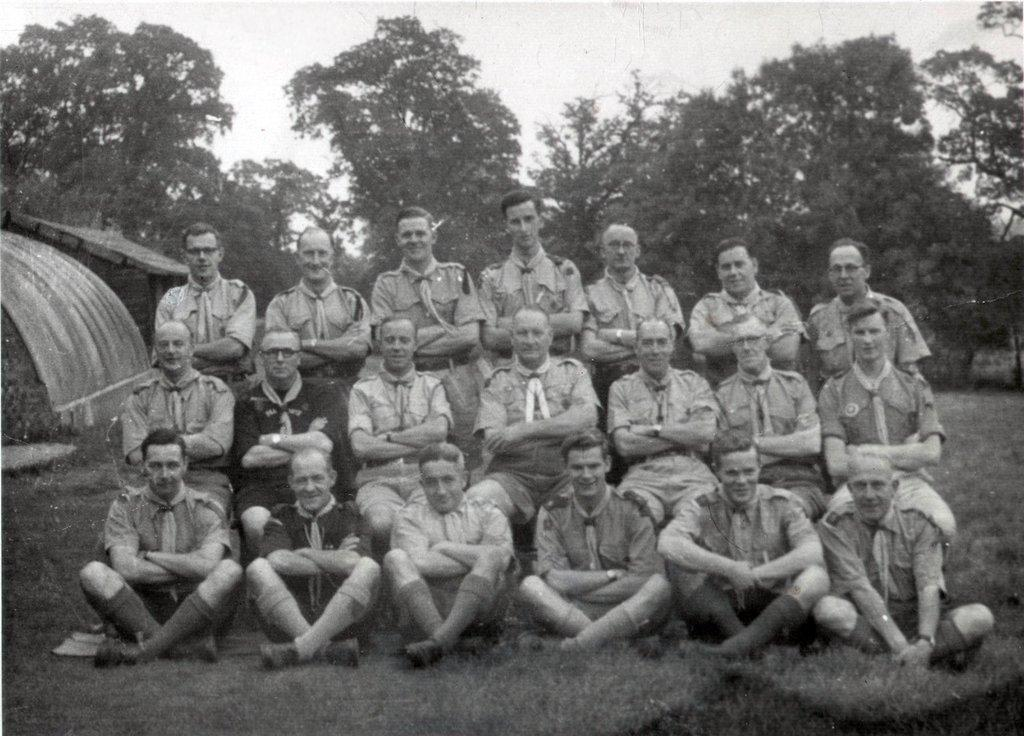What is the color scheme of the image? The image is black and white. What can be seen in the image? There is a group of people in the image. What are the people in the image doing? The people are posing for a camera. What is visible on the ground in the image? The ground is visible in the image. What can be seen in the background of the image? There are trees and the sky visible in the background of the image. What type of stick can be seen in the hands of the people in the image? There is no stick visible in the hands of the people in the image. Can you tell me where the nearest hospital is in relation to the location of the image? The text does not provide any information about the location of the image, so it is impossible to determine the nearest hospital. 